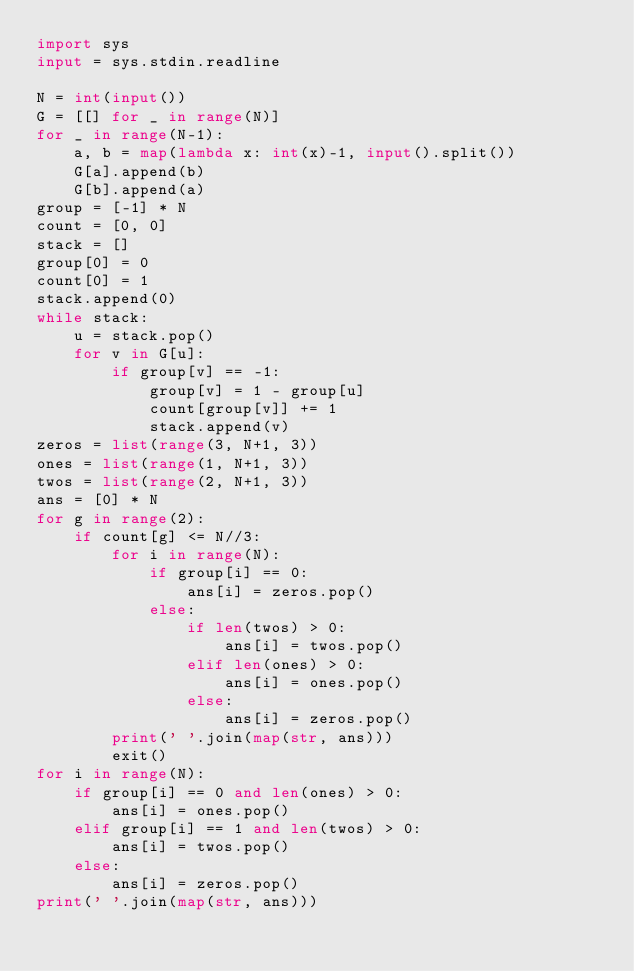Convert code to text. <code><loc_0><loc_0><loc_500><loc_500><_Python_>import sys
input = sys.stdin.readline

N = int(input())
G = [[] for _ in range(N)]
for _ in range(N-1):
    a, b = map(lambda x: int(x)-1, input().split())
    G[a].append(b)
    G[b].append(a)
group = [-1] * N
count = [0, 0]
stack = []
group[0] = 0
count[0] = 1
stack.append(0)
while stack:
    u = stack.pop()
    for v in G[u]:
        if group[v] == -1:
            group[v] = 1 - group[u]
            count[group[v]] += 1
            stack.append(v)
zeros = list(range(3, N+1, 3))
ones = list(range(1, N+1, 3))
twos = list(range(2, N+1, 3))
ans = [0] * N
for g in range(2):
    if count[g] <= N//3:
        for i in range(N):
            if group[i] == 0:
                ans[i] = zeros.pop()
            else:
                if len(twos) > 0:
                    ans[i] = twos.pop()
                elif len(ones) > 0:
                    ans[i] = ones.pop()
                else:
                    ans[i] = zeros.pop()
        print(' '.join(map(str, ans)))
        exit()
for i in range(N):
    if group[i] == 0 and len(ones) > 0:
        ans[i] = ones.pop()
    elif group[i] == 1 and len(twos) > 0:
        ans[i] = twos.pop()
    else:
        ans[i] = zeros.pop()
print(' '.join(map(str, ans)))
</code> 